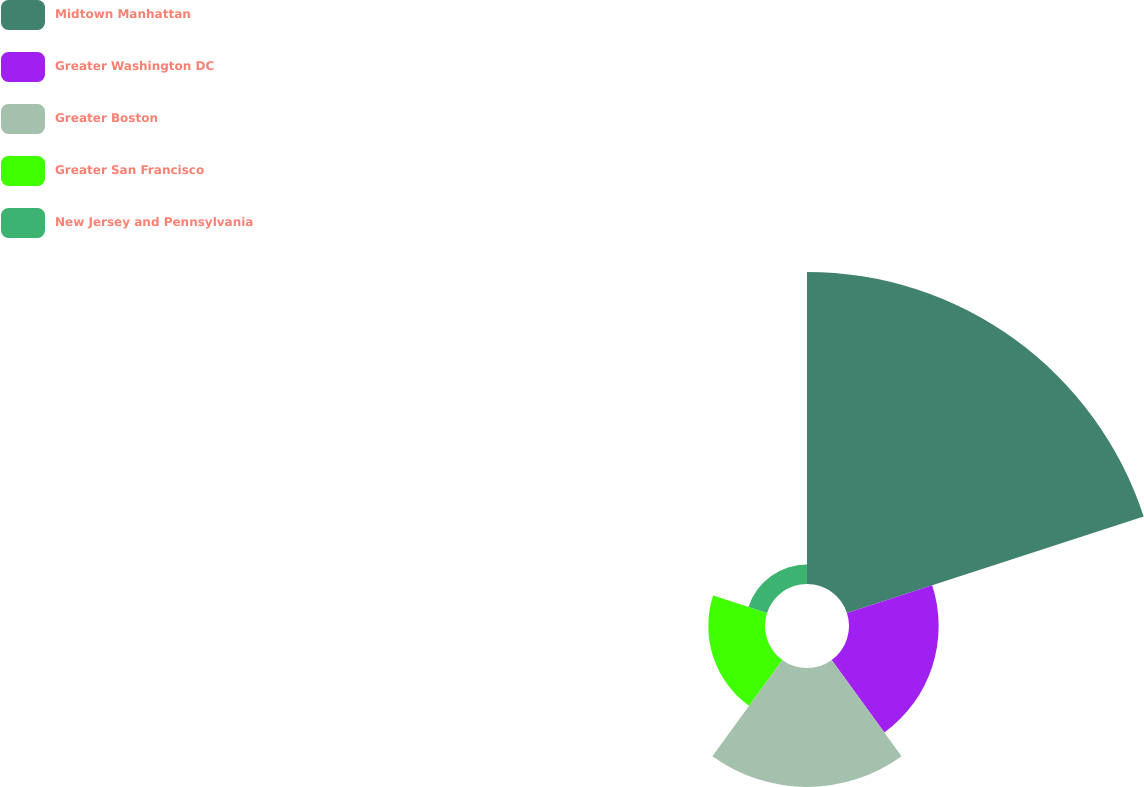Convert chart. <chart><loc_0><loc_0><loc_500><loc_500><pie_chart><fcel>Midtown Manhattan<fcel>Greater Washington DC<fcel>Greater Boston<fcel>Greater San Francisco<fcel>New Jersey and Pennsylvania<nl><fcel>52.28%<fcel>15.02%<fcel>19.92%<fcel>9.5%<fcel>3.27%<nl></chart> 